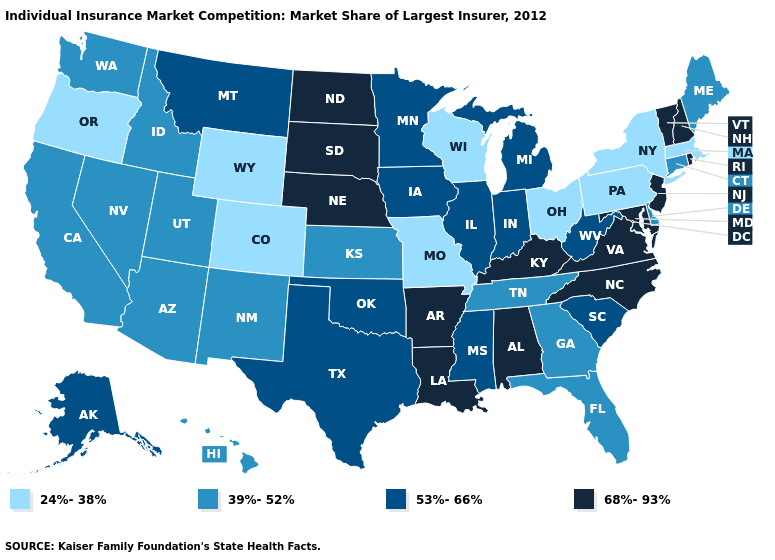Name the states that have a value in the range 53%-66%?
Keep it brief. Alaska, Illinois, Indiana, Iowa, Michigan, Minnesota, Mississippi, Montana, Oklahoma, South Carolina, Texas, West Virginia. Which states have the highest value in the USA?
Keep it brief. Alabama, Arkansas, Kentucky, Louisiana, Maryland, Nebraska, New Hampshire, New Jersey, North Carolina, North Dakota, Rhode Island, South Dakota, Vermont, Virginia. What is the value of Wyoming?
Concise answer only. 24%-38%. Does Alabama have the same value as South Carolina?
Keep it brief. No. Does the map have missing data?
Be succinct. No. Which states have the lowest value in the USA?
Answer briefly. Colorado, Massachusetts, Missouri, New York, Ohio, Oregon, Pennsylvania, Wisconsin, Wyoming. Among the states that border Delaware , which have the highest value?
Quick response, please. Maryland, New Jersey. What is the lowest value in the MidWest?
Be succinct. 24%-38%. What is the value of Utah?
Short answer required. 39%-52%. What is the value of Arkansas?
Be succinct. 68%-93%. Which states have the highest value in the USA?
Give a very brief answer. Alabama, Arkansas, Kentucky, Louisiana, Maryland, Nebraska, New Hampshire, New Jersey, North Carolina, North Dakota, Rhode Island, South Dakota, Vermont, Virginia. What is the value of Vermont?
Keep it brief. 68%-93%. What is the value of Montana?
Quick response, please. 53%-66%. What is the lowest value in the Northeast?
Quick response, please. 24%-38%. 